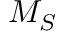Convert formula to latex. <formula><loc_0><loc_0><loc_500><loc_500>M _ { S }</formula> 